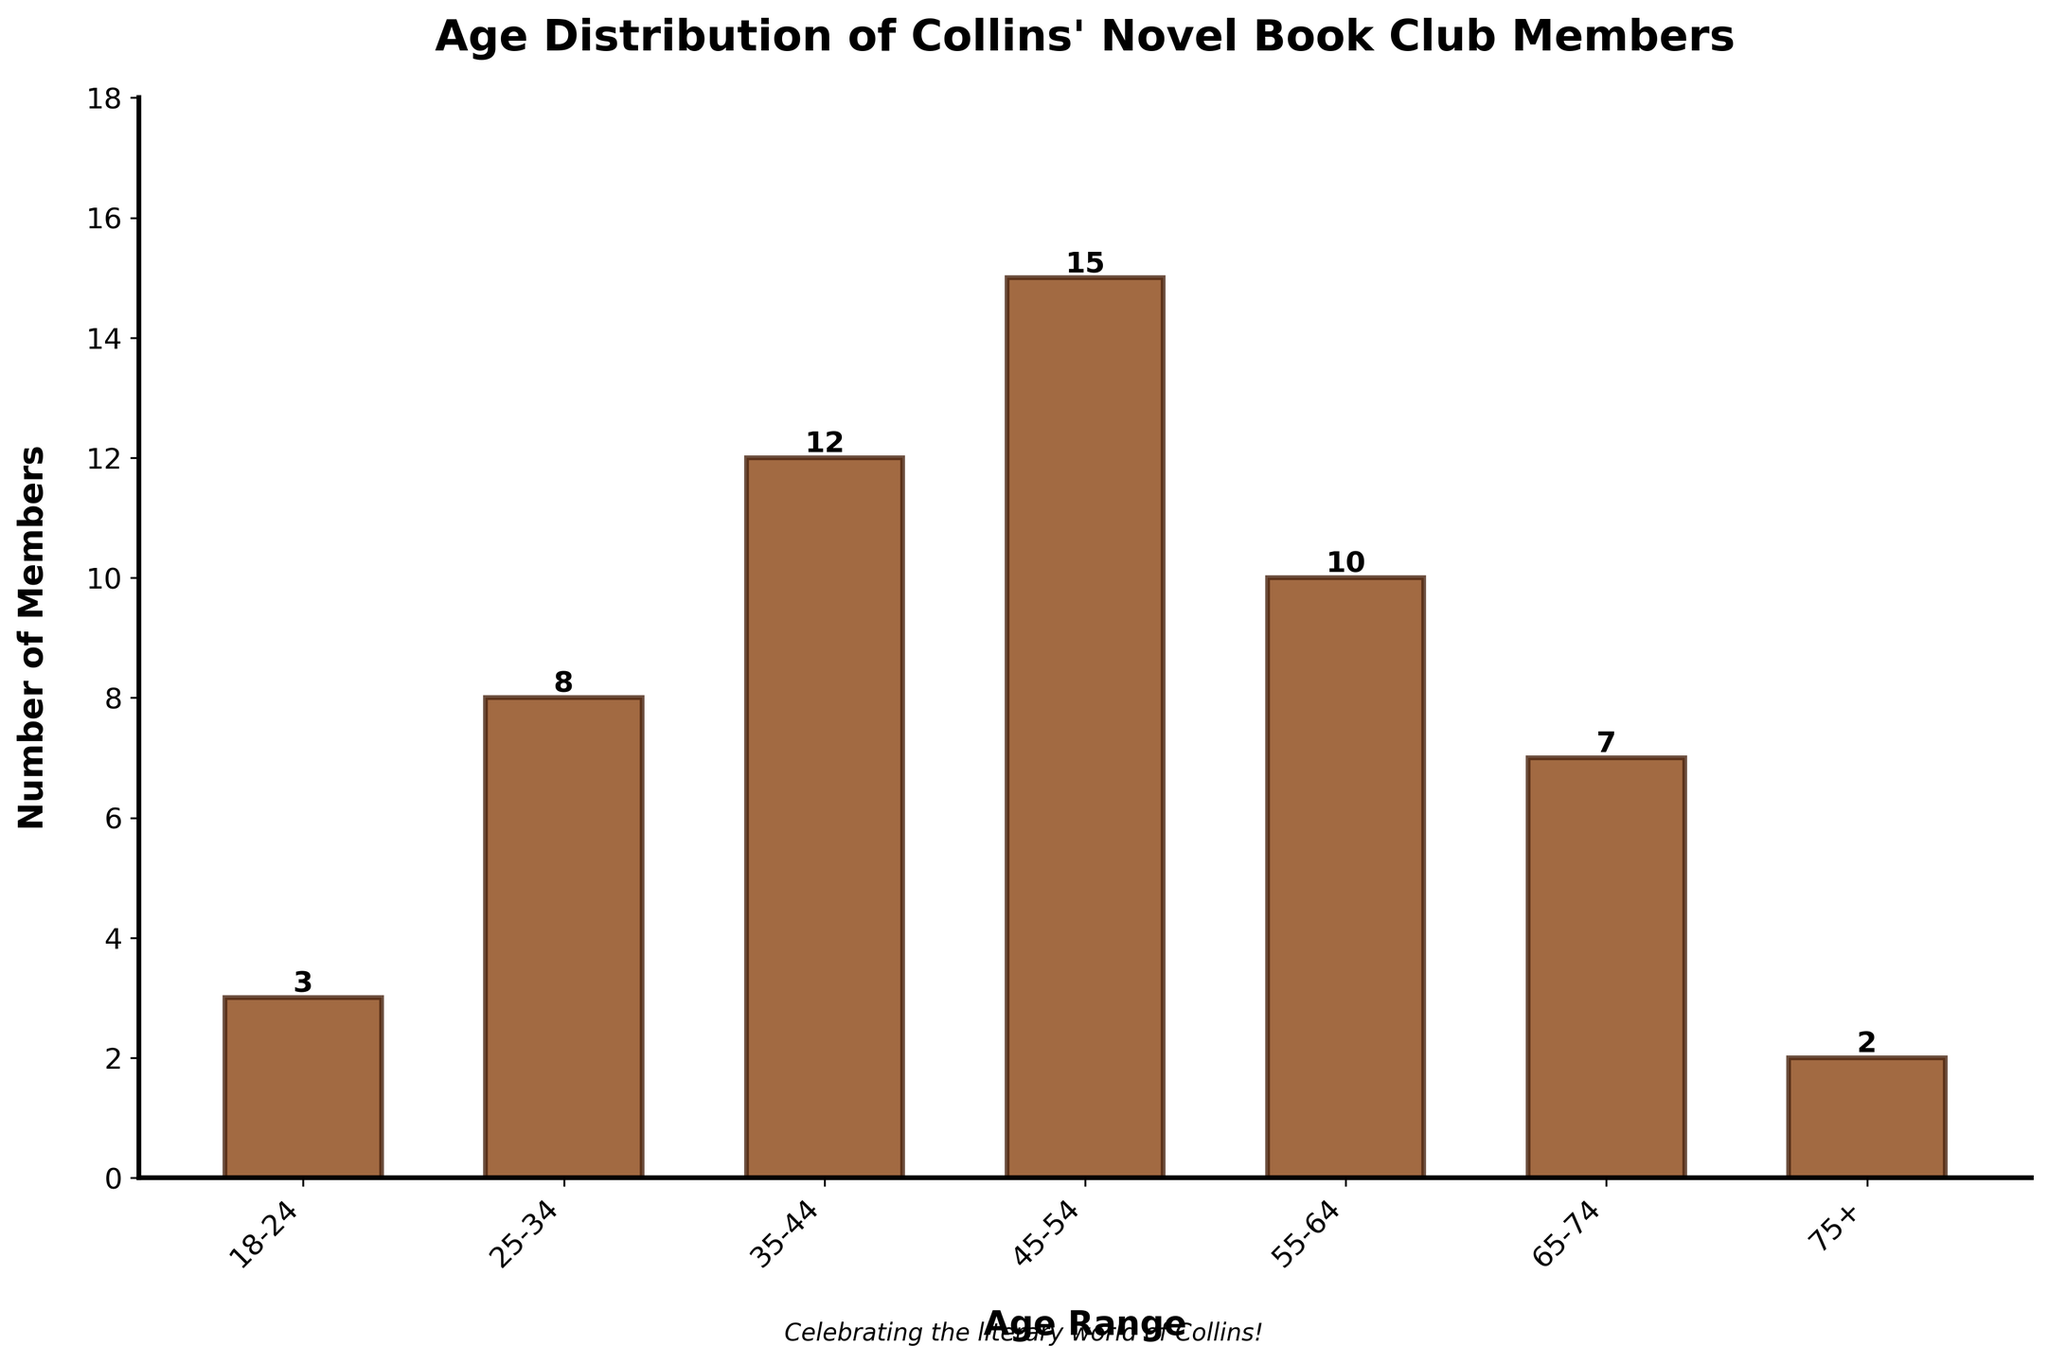Which age range has the highest number of book club members? By looking at the heights of the bars representing each age range, the tallest bar corresponds to the 45-54 age range, indicating it has the highest number of members.
Answer: 45-54 What is the total number of book club members aged 35-54? Add the number of members for the 35-44 and 45-54 age ranges: 12 (35-44) + 15 (45-54) = 27.
Answer: 27 Which age range has the fewest book club members? Identify the shortest bar in the chart. The bar for the 75+ age range is the shortest.
Answer: 75+ How many more members are there in the 45-54 age range compared to the 55-64 age range? Subtract the number of members in the 55-64 age range from the number in the 45-54 age range: 15 (45-54) - 10 (55-64) = 5.
Answer: 5 What is the average number of members per age range? Sum the number of members for all age ranges and divide by the number of age ranges: (3 + 8 + 12 + 15 + 10 + 7 + 2) / 7 = 57 / 7 = ~8.14.
Answer: ~8.14 Are there more members in the 25-34 age range or the 65-74 age range? Compare the number of members in the 25-34 age range (8) to the 65-74 age range (7). The 25-34 age range has more members.
Answer: 25-34 What is the difference in number of members between the age ranges with the second highest and the second lowest count? Identify the second highest count (35-44 with 12 members) and the second lowest count (65-74 with 7 members). Subtract the two: 12 - 7 = 5.
Answer: 5 Which age range shows exactly half the number of members as the range with the most members? The range with the most members is 45-54 with 15 members. Half of 15 is 7.5, which rounds to 8. The 25-34 age range has 8 members.
Answer: 25-34 How does the number of members in the 18-24 age range compare to the 75+ age range? Compare the number of members in each range: 3 (18-24) vs. 2 (75+). The 18-24 age range has 1 more member.
Answer: 18-24 